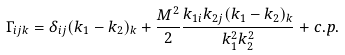Convert formula to latex. <formula><loc_0><loc_0><loc_500><loc_500>\Gamma _ { i j k } = \delta _ { i j } ( k _ { 1 } - k _ { 2 } ) _ { k } + \frac { M ^ { 2 } } { 2 } \frac { k _ { 1 i } k _ { 2 j } ( k _ { 1 } - k _ { 2 } ) _ { k } } { k _ { 1 } ^ { 2 } k _ { 2 } ^ { 2 } } + c . p .</formula> 